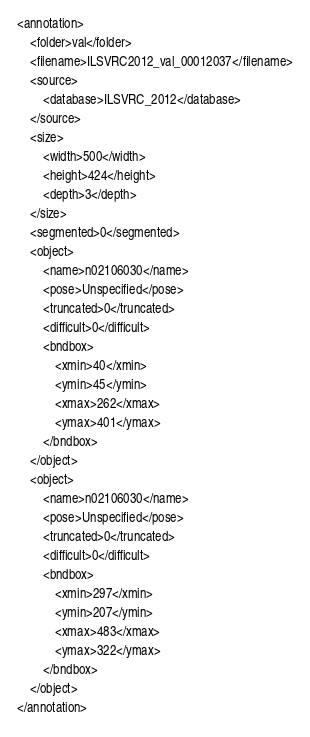<code> <loc_0><loc_0><loc_500><loc_500><_XML_><annotation>
	<folder>val</folder>
	<filename>ILSVRC2012_val_00012037</filename>
	<source>
		<database>ILSVRC_2012</database>
	</source>
	<size>
		<width>500</width>
		<height>424</height>
		<depth>3</depth>
	</size>
	<segmented>0</segmented>
	<object>
		<name>n02106030</name>
		<pose>Unspecified</pose>
		<truncated>0</truncated>
		<difficult>0</difficult>
		<bndbox>
			<xmin>40</xmin>
			<ymin>45</ymin>
			<xmax>262</xmax>
			<ymax>401</ymax>
		</bndbox>
	</object>
	<object>
		<name>n02106030</name>
		<pose>Unspecified</pose>
		<truncated>0</truncated>
		<difficult>0</difficult>
		<bndbox>
			<xmin>297</xmin>
			<ymin>207</ymin>
			<xmax>483</xmax>
			<ymax>322</ymax>
		</bndbox>
	</object>
</annotation></code> 